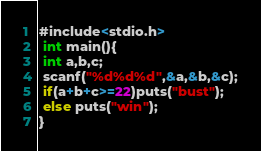<code> <loc_0><loc_0><loc_500><loc_500><_C#_>#include<stdio.h>
 int main(){
 int a,b,c;
 scanf("%d%d%d",&a,&b,&c);
 if(a+b+c>=22)puts("bust");
 else puts("win");
}</code> 